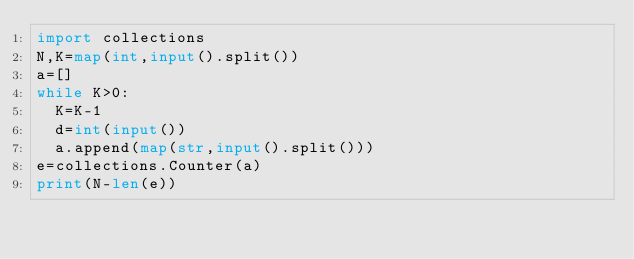<code> <loc_0><loc_0><loc_500><loc_500><_Python_>import collections
N,K=map(int,input().split())
a=[]
while K>0:
  K=K-1
  d=int(input())
  a.append(map(str,input().split()))
e=collections.Counter(a)
print(N-len(e))</code> 